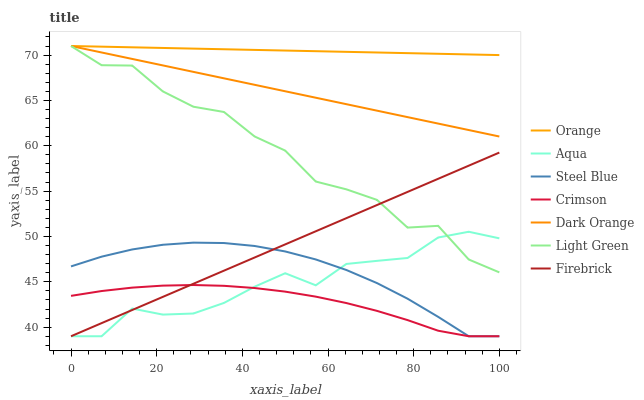Does Crimson have the minimum area under the curve?
Answer yes or no. Yes. Does Orange have the maximum area under the curve?
Answer yes or no. Yes. Does Firebrick have the minimum area under the curve?
Answer yes or no. No. Does Firebrick have the maximum area under the curve?
Answer yes or no. No. Is Firebrick the smoothest?
Answer yes or no. Yes. Is Light Green the roughest?
Answer yes or no. Yes. Is Aqua the smoothest?
Answer yes or no. No. Is Aqua the roughest?
Answer yes or no. No. Does Firebrick have the lowest value?
Answer yes or no. Yes. Does Light Green have the lowest value?
Answer yes or no. No. Does Orange have the highest value?
Answer yes or no. Yes. Does Firebrick have the highest value?
Answer yes or no. No. Is Steel Blue less than Light Green?
Answer yes or no. Yes. Is Orange greater than Firebrick?
Answer yes or no. Yes. Does Orange intersect Light Green?
Answer yes or no. Yes. Is Orange less than Light Green?
Answer yes or no. No. Is Orange greater than Light Green?
Answer yes or no. No. Does Steel Blue intersect Light Green?
Answer yes or no. No. 